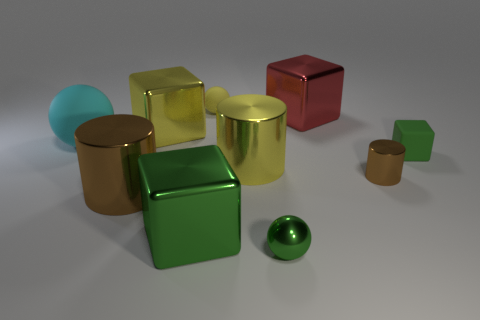Subtract all gray spheres. How many green blocks are left? 2 Subtract all large green blocks. How many blocks are left? 3 Subtract 1 blocks. How many blocks are left? 3 Subtract all yellow blocks. How many blocks are left? 3 Subtract all brown cubes. Subtract all green balls. How many cubes are left? 4 Subtract all cubes. How many objects are left? 6 Add 8 green shiny balls. How many green shiny balls exist? 9 Subtract 1 yellow cylinders. How many objects are left? 9 Subtract all large shiny blocks. Subtract all large cyan matte things. How many objects are left? 6 Add 6 red metal cubes. How many red metal cubes are left? 7 